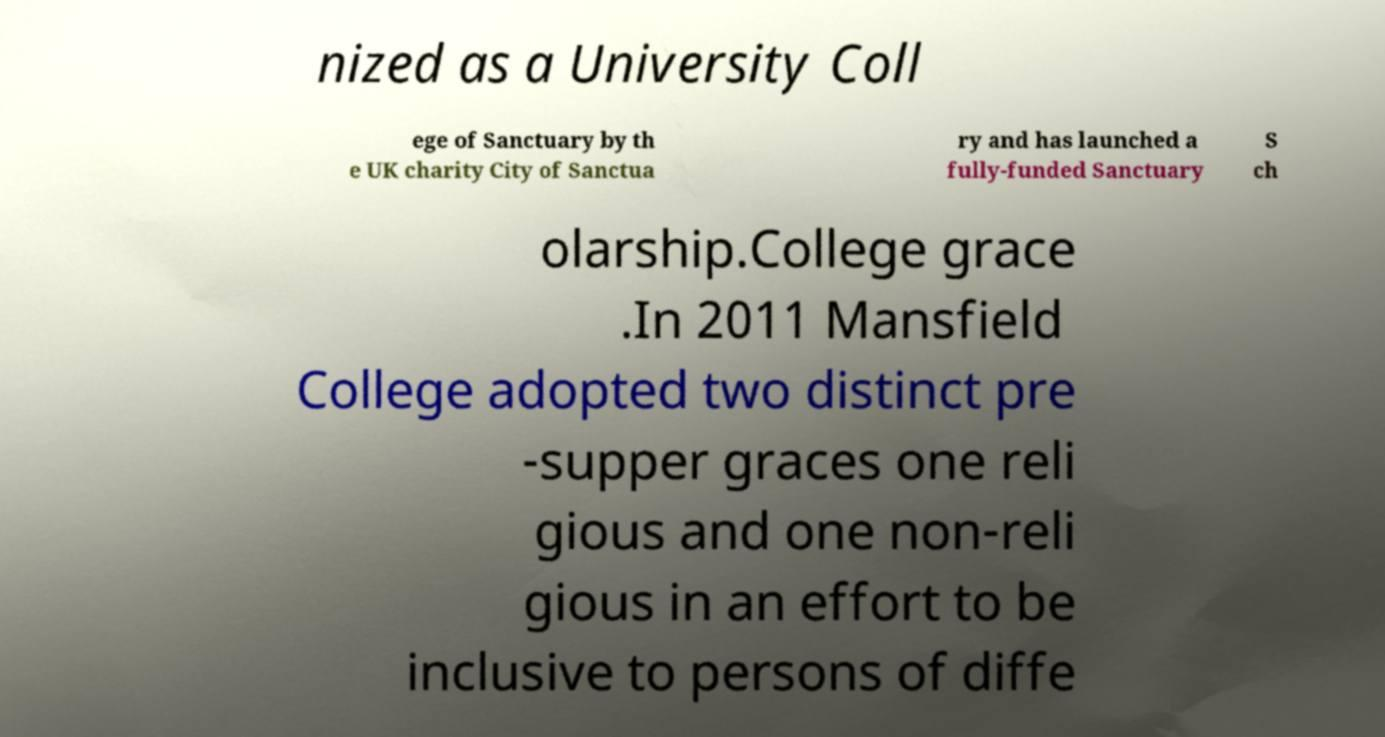Could you extract and type out the text from this image? nized as a University Coll ege of Sanctuary by th e UK charity City of Sanctua ry and has launched a fully-funded Sanctuary S ch olarship.College grace .In 2011 Mansfield College adopted two distinct pre -supper graces one reli gious and one non-reli gious in an effort to be inclusive to persons of diffe 